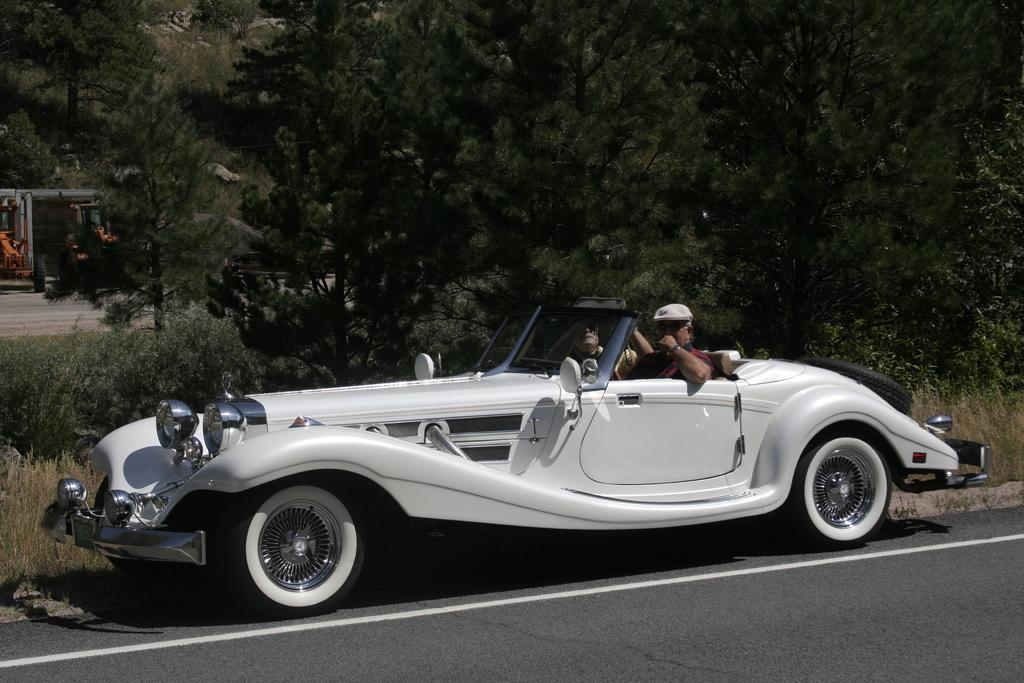What type of vehicle is in the image? There is a white car in the image. Who is inside the car? Two persons are sitting in the car. What can be seen in the background of the image? There are trees visible in the image. What type of fruit is hanging from the trees in the image? There is no fruit visible in the image; only trees are mentioned in the background. 